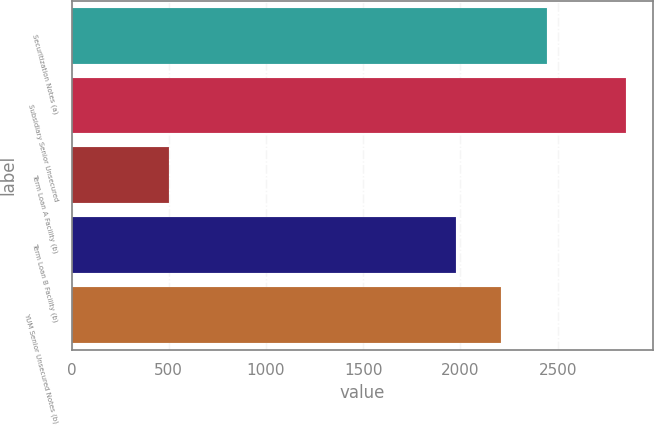<chart> <loc_0><loc_0><loc_500><loc_500><bar_chart><fcel>Securitization Notes (a)<fcel>Subsidiary Senior Unsecured<fcel>Term Loan A Facility (b)<fcel>Term Loan B Facility (b)<fcel>YUM Senior Unsecured Notes (b)<nl><fcel>2445<fcel>2850<fcel>500<fcel>1975<fcel>2210<nl></chart> 